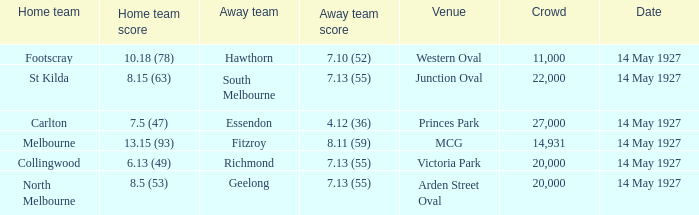Which away team had a score of 4.12 (36)? Essendon. 